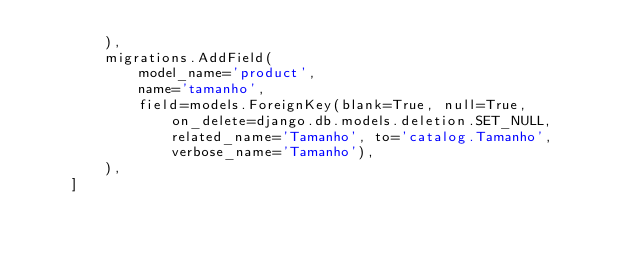<code> <loc_0><loc_0><loc_500><loc_500><_Python_>        ),
        migrations.AddField(
            model_name='product',
            name='tamanho',
            field=models.ForeignKey(blank=True, null=True, on_delete=django.db.models.deletion.SET_NULL, related_name='Tamanho', to='catalog.Tamanho', verbose_name='Tamanho'),
        ),
    ]
</code> 